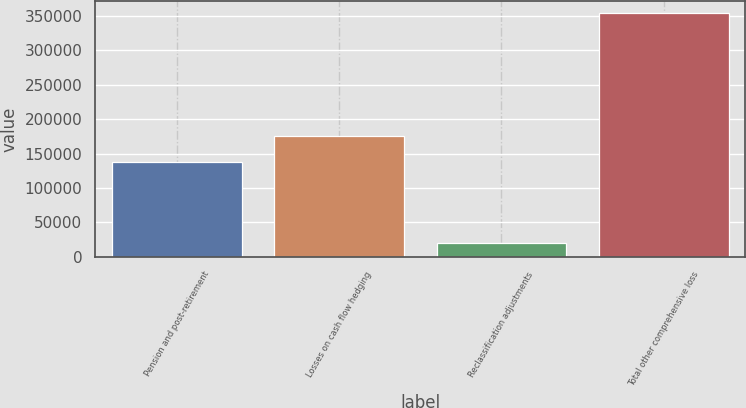Convert chart to OTSL. <chart><loc_0><loc_0><loc_500><loc_500><bar_chart><fcel>Pension and post-retirement<fcel>Losses on cash flow hedging<fcel>Reclassification adjustments<fcel>Total other comprehensive loss<nl><fcel>137918<fcel>175011<fcel>20282<fcel>354424<nl></chart> 